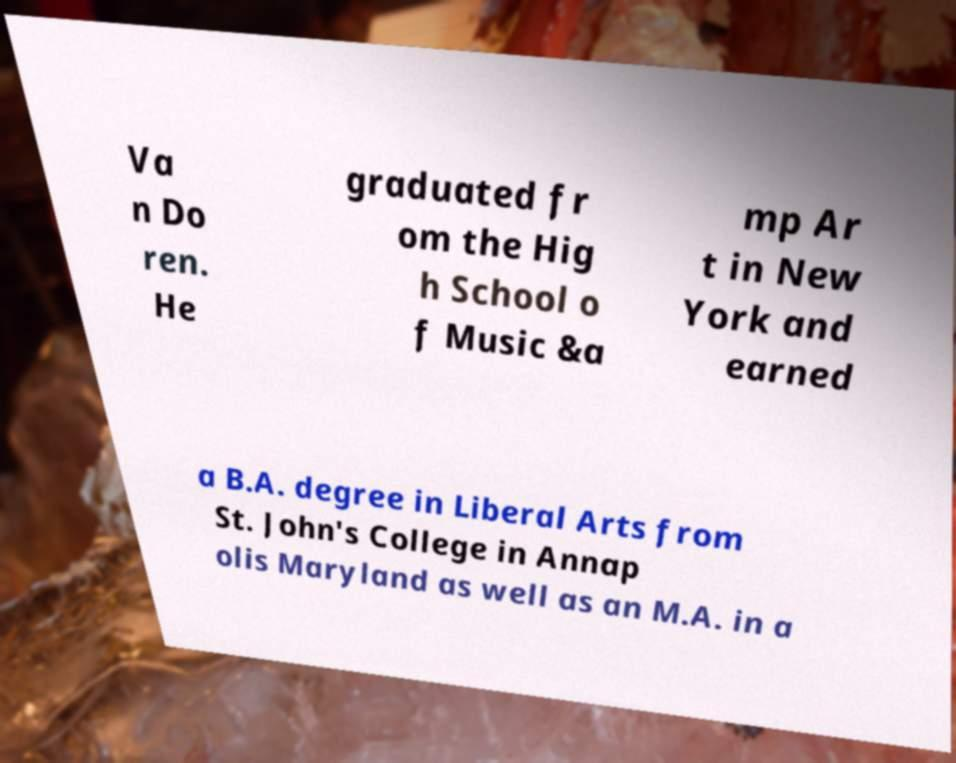Can you accurately transcribe the text from the provided image for me? Va n Do ren. He graduated fr om the Hig h School o f Music &a mp Ar t in New York and earned a B.A. degree in Liberal Arts from St. John's College in Annap olis Maryland as well as an M.A. in a 